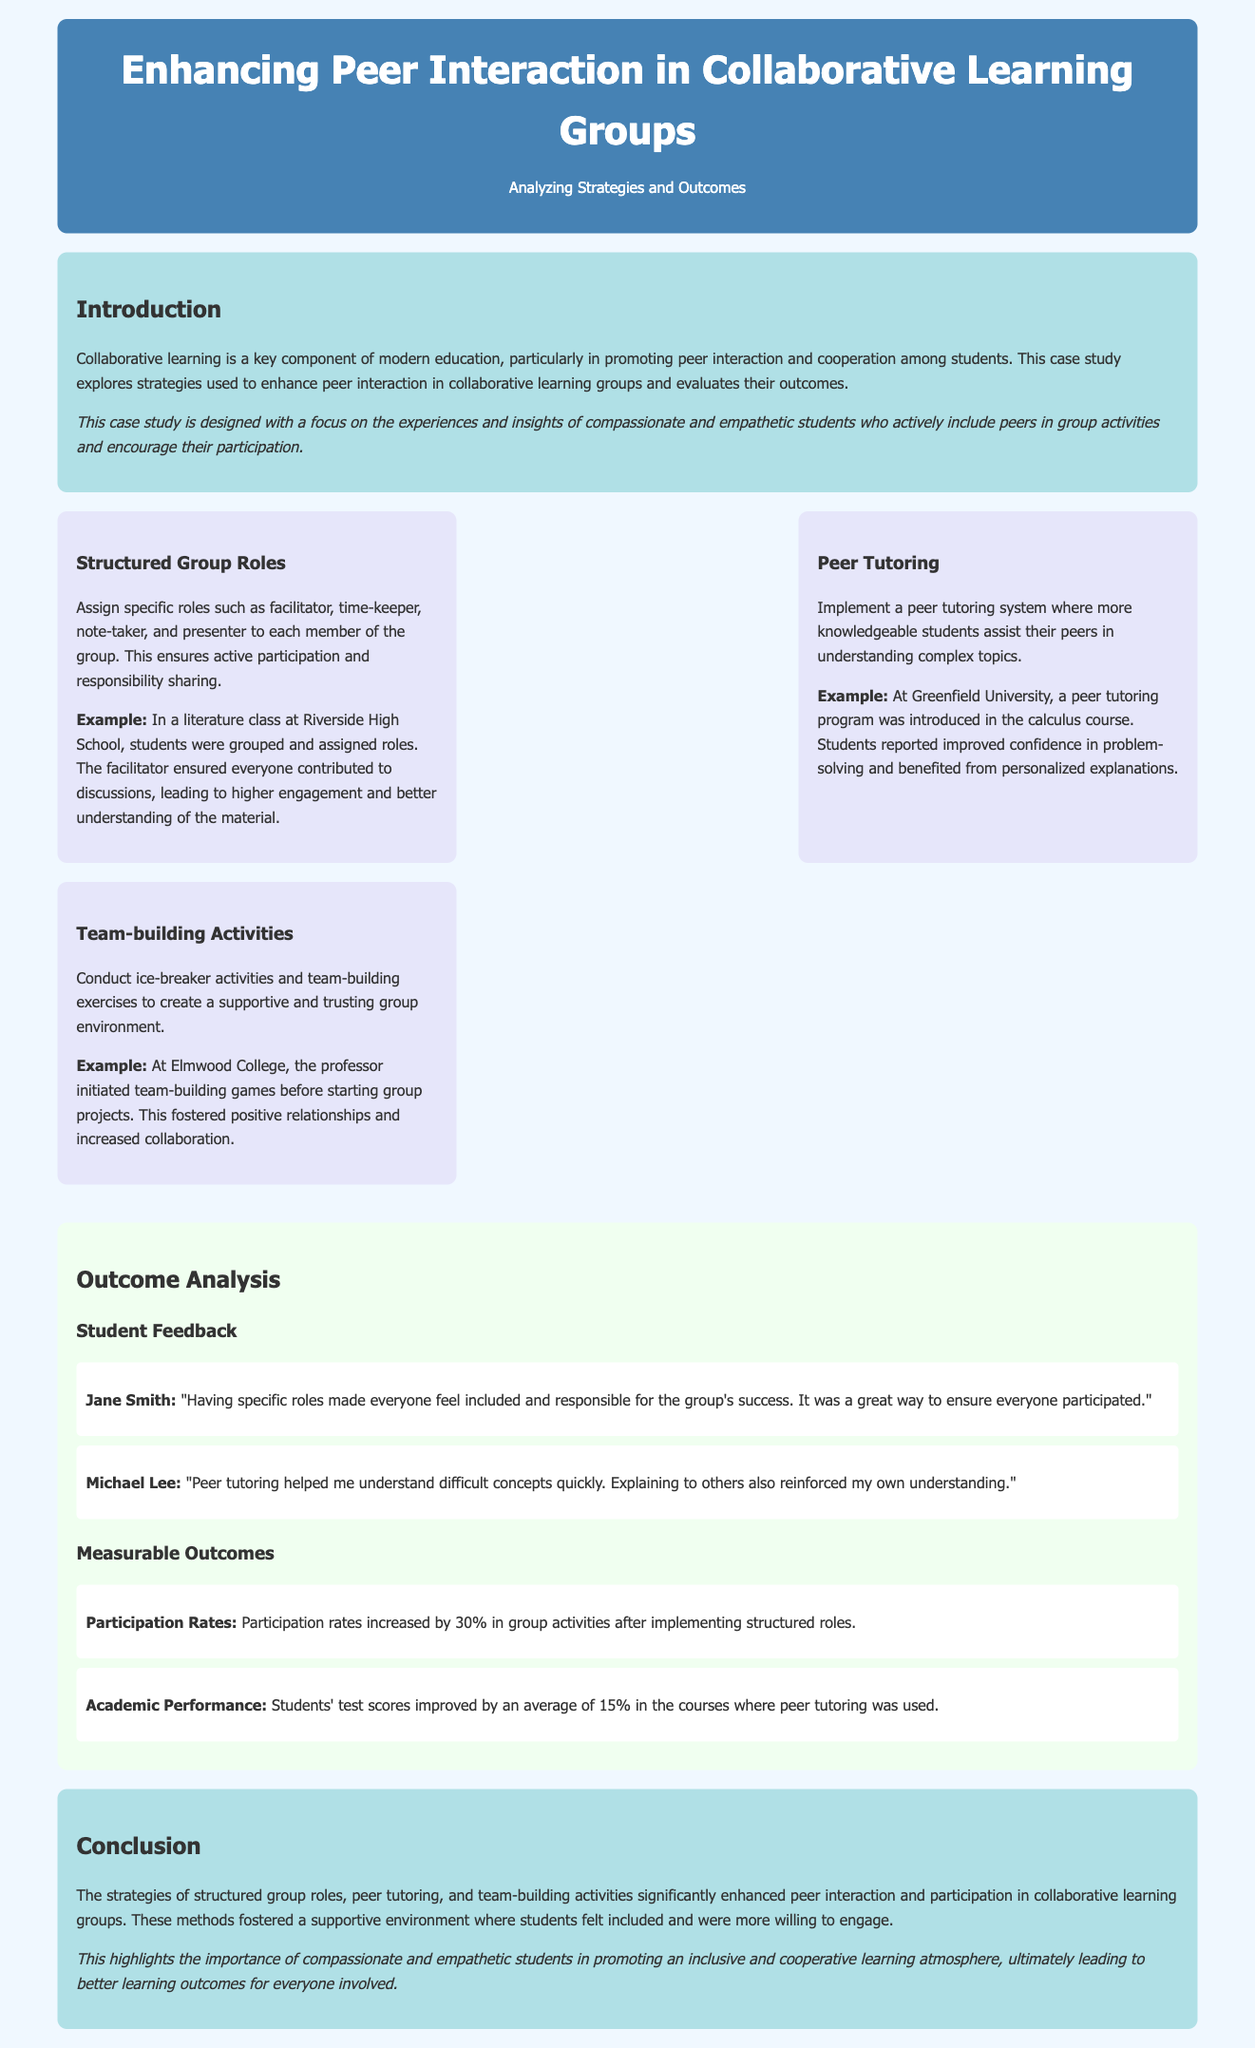What are the three strategies discussed? The three strategies mentioned in the document are structured group roles, peer tutoring, and team-building activities.
Answer: structured group roles, peer tutoring, team-building activities What percentage did participation rates increase? The document states that participation rates increased by 30% after implementing structured roles.
Answer: 30% What was the average improvement in test scores? According to the document, students' test scores improved by an average of 15% in the courses where peer tutoring was used.
Answer: 15% Who benefited from the peer tutoring program? The document highlights that more knowledgeable students assisted their peers, indicating that both groups benefitted from the peer tutoring program.
Answer: more knowledgeable students, peers What was Jane Smith's feedback on structured roles? Jane Smith indicated that having specific roles ensured everyone participated and felt responsible for the group's success.
Answer: "everyone feel included and responsible" What activity was conducted to create a supportive environment? The document mentions that team-building activities were conducted to create a supportive and trusting group environment.
Answer: team-building activities Where was the peer tutoring program introduced? The peer tutoring program was introduced at Greenfield University as mentioned in the document.
Answer: Greenfield University What is a key component of modern education highlighted in the introduction? The introduction emphasizes that collaborative learning is a key component of modern education.
Answer: collaborative learning Why are compassionate and empathetic students important according to the conclusion? The conclusion mentions that compassionate and empathetic students promote an inclusive and cooperative learning atmosphere.
Answer: promote an inclusive and cooperative learning atmosphere 